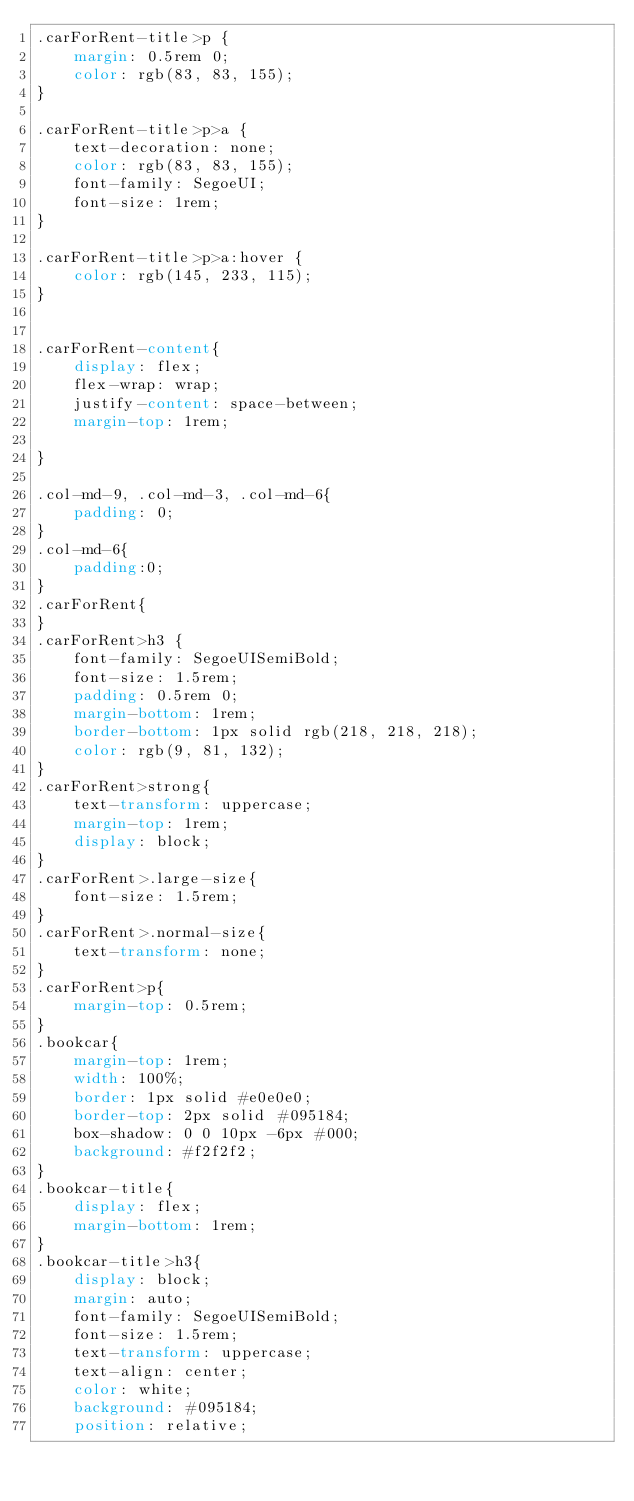Convert code to text. <code><loc_0><loc_0><loc_500><loc_500><_CSS_>.carForRent-title>p {
    margin: 0.5rem 0;
    color: rgb(83, 83, 155);
}

.carForRent-title>p>a {
    text-decoration: none;
    color: rgb(83, 83, 155);
    font-family: SegoeUI;
    font-size: 1rem;
}

.carForRent-title>p>a:hover {
    color: rgb(145, 233, 115);
}


.carForRent-content{
    display: flex;
    flex-wrap: wrap;
    justify-content: space-between;
    margin-top: 1rem;
  
}

.col-md-9, .col-md-3, .col-md-6{
    padding: 0;
}
.col-md-6{
    padding:0;
}
.carForRent{
}
.carForRent>h3 {
    font-family: SegoeUISemiBold;
    font-size: 1.5rem;
    padding: 0.5rem 0;
    margin-bottom: 1rem;
    border-bottom: 1px solid rgb(218, 218, 218);
    color: rgb(9, 81, 132);
}
.carForRent>strong{
    text-transform: uppercase;
    margin-top: 1rem;
    display: block;
}
.carForRent>.large-size{
    font-size: 1.5rem;
}
.carForRent>.normal-size{
    text-transform: none;
}
.carForRent>p{ 
    margin-top: 0.5rem;
}
.bookcar{
    margin-top: 1rem;
    width: 100%;
    border: 1px solid #e0e0e0;
    border-top: 2px solid #095184;
    box-shadow: 0 0 10px -6px #000;
    background: #f2f2f2;
}
.bookcar-title{
    display: flex;
    margin-bottom: 1rem;
}
.bookcar-title>h3{
    display: block;
    margin: auto;
    font-family: SegoeUISemiBold;
    font-size: 1.5rem;
    text-transform: uppercase;
    text-align: center;
    color: white;
    background: #095184;
    position: relative;</code> 